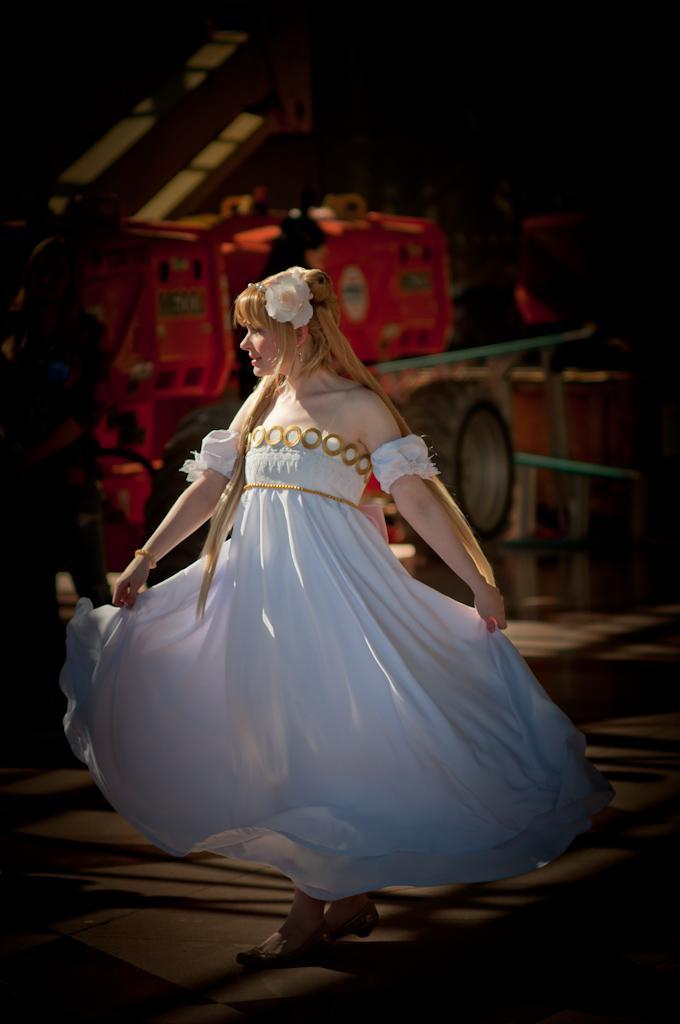Could you give a brief overview of what you see in this image? In the center of the image we can see a lady wearing a white dress. In the background we can see a vehicle. At the bottom there is a road. 